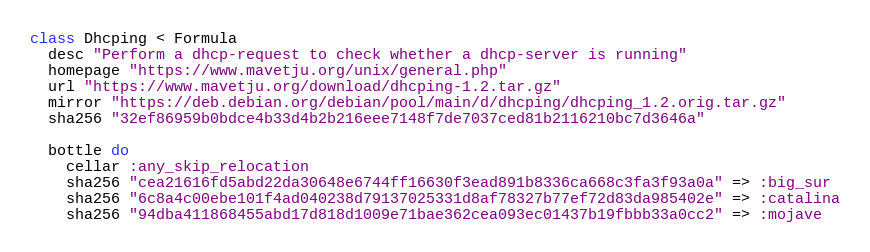Convert code to text. <code><loc_0><loc_0><loc_500><loc_500><_Ruby_>class Dhcping < Formula
  desc "Perform a dhcp-request to check whether a dhcp-server is running"
  homepage "https://www.mavetju.org/unix/general.php"
  url "https://www.mavetju.org/download/dhcping-1.2.tar.gz"
  mirror "https://deb.debian.org/debian/pool/main/d/dhcping/dhcping_1.2.orig.tar.gz"
  sha256 "32ef86959b0bdce4b33d4b2b216eee7148f7de7037ced81b2116210bc7d3646a"

  bottle do
    cellar :any_skip_relocation
    sha256 "cea21616fd5abd22da30648e6744ff16630f3ead891b8336ca668c3fa3f93a0a" => :big_sur
    sha256 "6c8a4c00ebe101f4ad040238d79137025331d8af78327b77ef72d83da985402e" => :catalina
    sha256 "94dba411868455abd17d818d1009e71bae362cea093ec01437b19fbbb33a0cc2" => :mojave</code> 